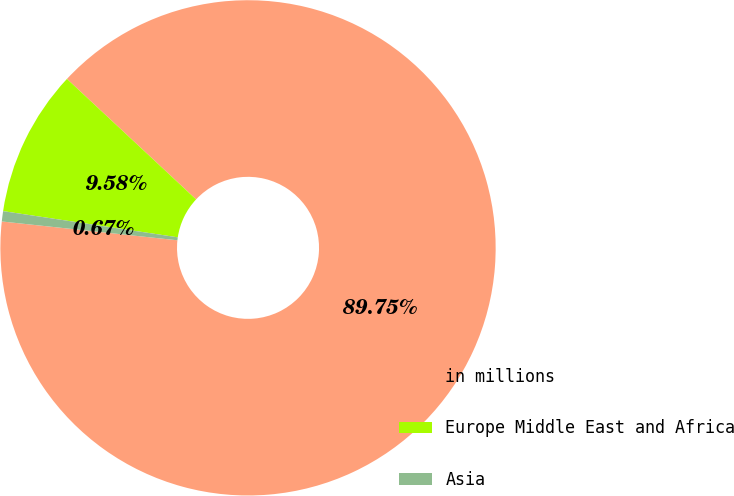Convert chart. <chart><loc_0><loc_0><loc_500><loc_500><pie_chart><fcel>in millions<fcel>Europe Middle East and Africa<fcel>Asia<nl><fcel>89.76%<fcel>9.58%<fcel>0.67%<nl></chart> 